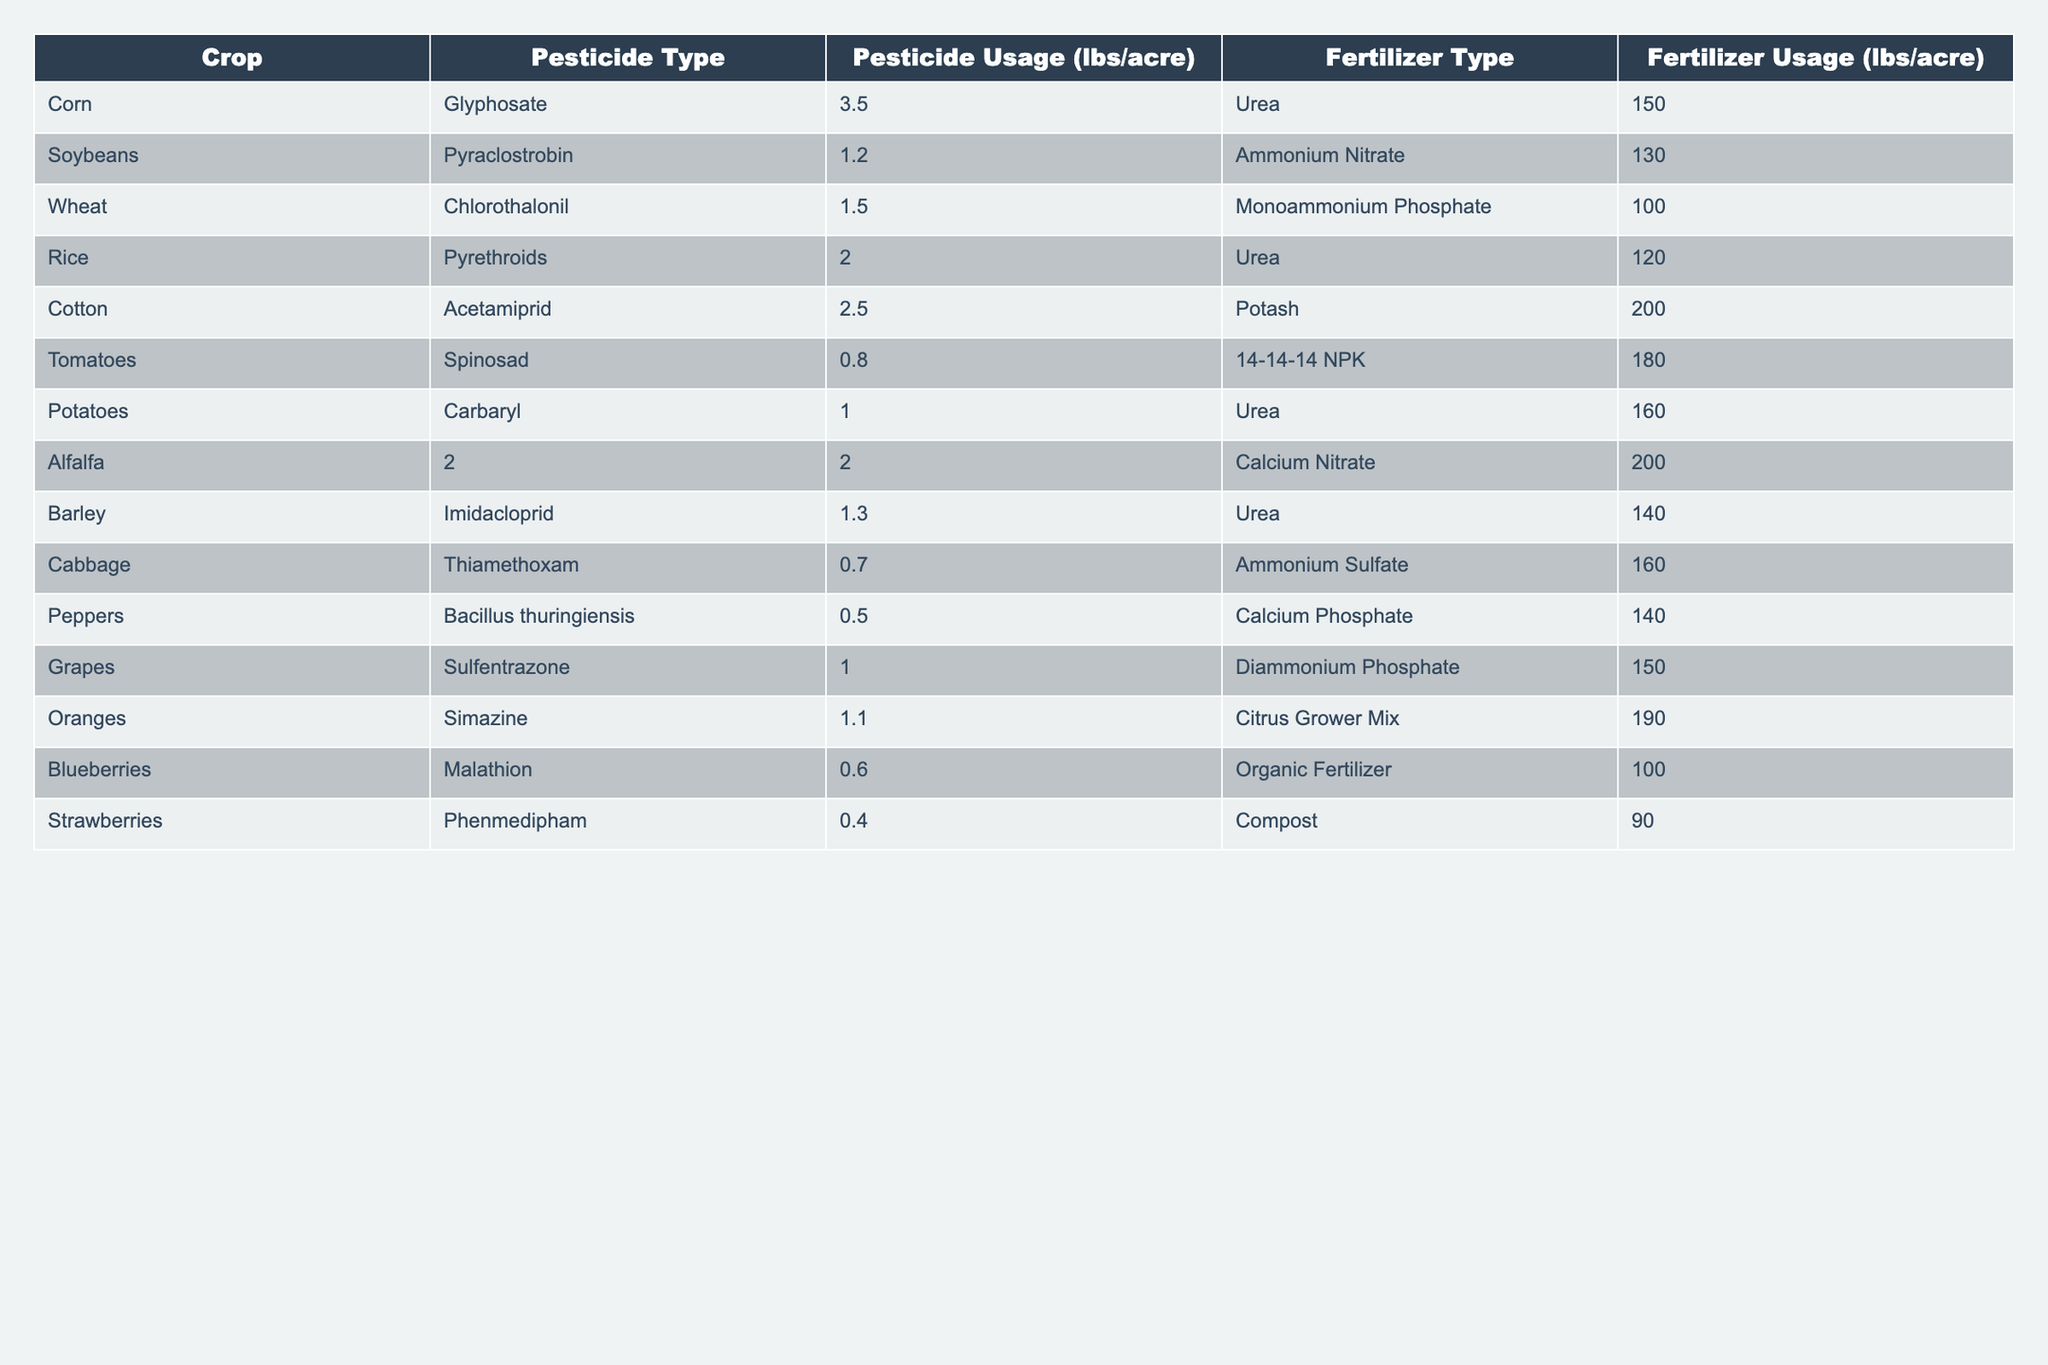What is the pesticide usage for corn? The table shows a row for corn where the pesticide used is Glyphosate with a usage of 3.5 lbs/acre.
Answer: 3.5 lbs/acre Which crop has the highest fertilizer usage? To find the highest fertilizer usage, we compare the fertilizer usage values from all the crops listed in the table. Cotton has the highest usage at 200 lbs/acre.
Answer: Cotton What is the average pesticide usage across all crops? First, we sum the pesticide usage values: 3.5 + 1.2 + 1.5 + 2.0 + 2.5 + 0.8 + 1.0 + 2 + 1.3 + 0.7 + 0.5 + 1.0 + 1.1 + 0.6 + 0.4 =  18.7 lbs/acre. There are 15 crops, so the average is 18.7/15 = 1.2467 lbs/acre.
Answer: Approximately 1.25 lbs/acre Is it true that all crops use urea as a fertilizer? By examining the fertilizer types in the table, we find that not all crops use urea; some use ammonium nitrate, potash, calcium nitrate, ammonium sulfate, and others, indicating a mix of fertilizers.
Answer: No Which crop uses the least amount of pesticide? By checking each crop's pesticide usage, we find that strawberries have the lowest usage at 0.4 lbs/acre compared to the others.
Answer: Strawberries How much pesticide is used for tomatoes compared to grapes? The pesticide usage for tomatoes is 0.8 lbs/acre and for grapes, it is 1.0 lbs/acre. Therefore, grapes use more pesticide than tomatoes by 0.2 lbs/acre.
Answer: Grapes use 0.2 lbs/acre more Is the fertilizer usage for alfalfa and potatoes the same? Looking at the fertilizer usage for alfalfa (200 lbs/acre) and potatoes (160 lbs/acre), they are not the same. Alfalfa uses more fertilizer.
Answer: No What is the total pesticide usage for all crops that utilize Glyphosate or Urea as a fertilizer? The crops that use Glyphosate (corn) have a pesticide usage of 3.5 lbs/acre. The crops that use Urea (corn, rice, and potatoes) have pesticide usages of 3.5 from corn, 2.0 from rice, and 1.0 from potatoes, totaling 3.5 + 2.0 + 1.0 = 6.5 lbs/acre.
Answer: 6.5 lbs/acre 